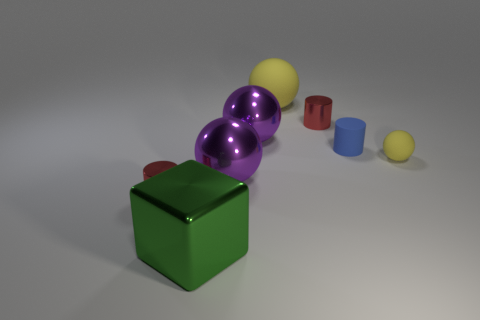There is a tiny yellow object; what shape is it?
Offer a terse response. Sphere. What number of purple things are made of the same material as the big green thing?
Make the answer very short. 2. Does the big matte thing have the same color as the ball right of the big yellow sphere?
Provide a succinct answer. Yes. How many large green objects are there?
Give a very brief answer. 1. Are there any big things of the same color as the small sphere?
Make the answer very short. Yes. There is a matte ball that is behind the yellow rubber ball in front of the red shiny cylinder on the right side of the large yellow matte object; what is its color?
Ensure brevity in your answer.  Yellow. Is the material of the blue object the same as the tiny cylinder left of the green block?
Keep it short and to the point. No. What is the large green block made of?
Your answer should be compact. Metal. What number of other objects are there of the same material as the large yellow ball?
Your answer should be compact. 2. There is a tiny object that is both left of the blue thing and right of the green cube; what shape is it?
Your answer should be very brief. Cylinder. 